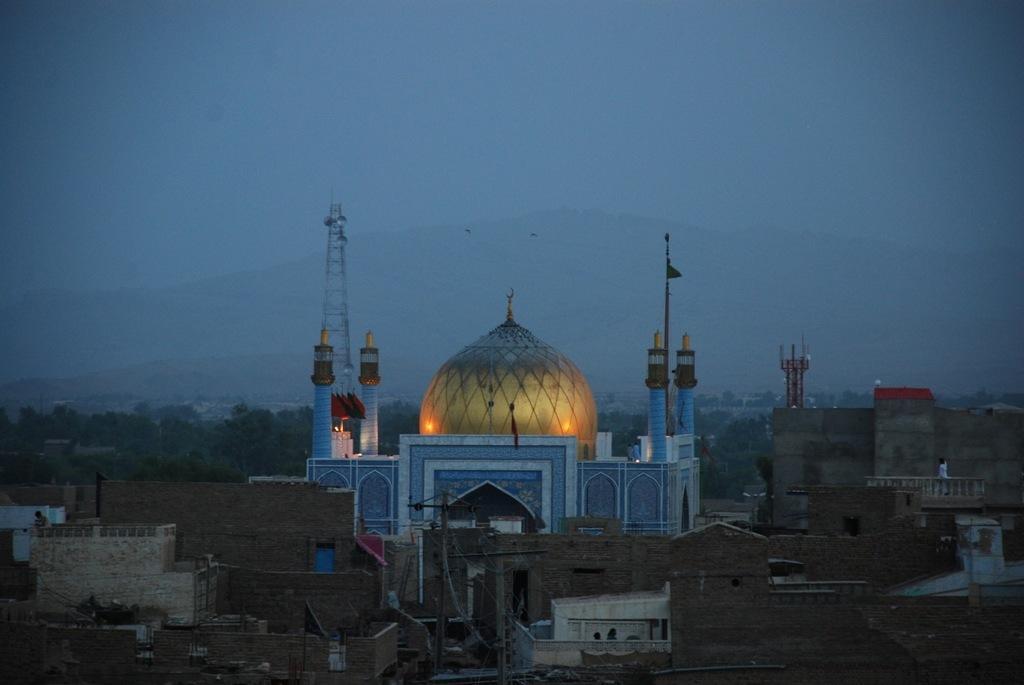How would you summarize this image in a sentence or two? In this image in the center there are buildings. In the background there are trees and there is a tower. 